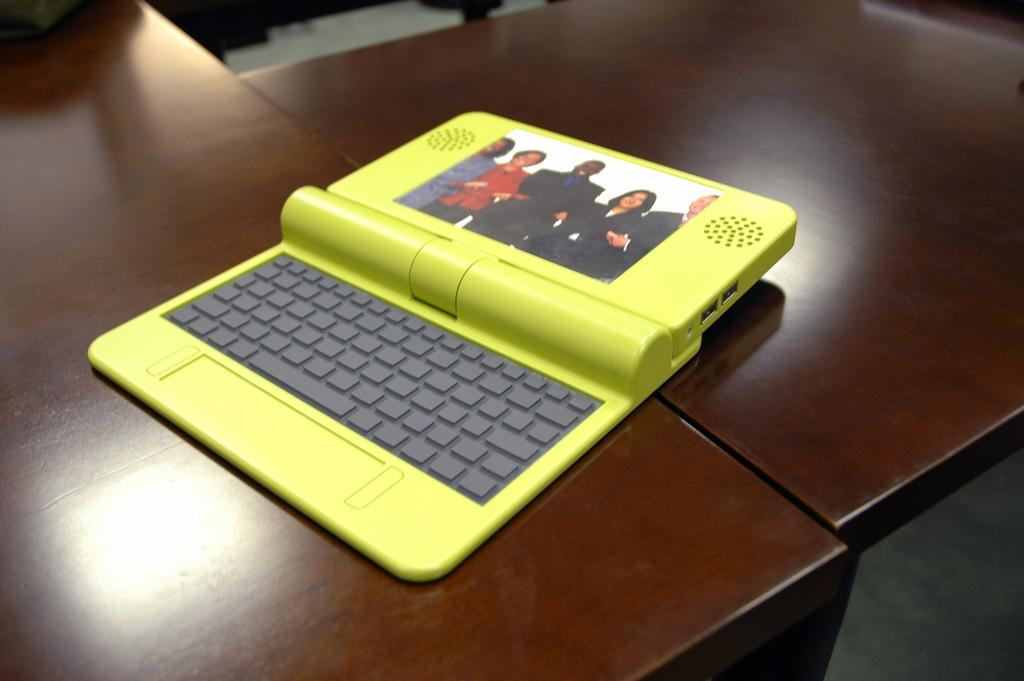What piece of furniture is present in the image? There is a table in the image. What object is placed on the table? There is a laptop on the table. Where can you find popcorn in the image? There is no popcorn present in the image. What type of government is depicted in the image? There is no reference to any government in the image. 